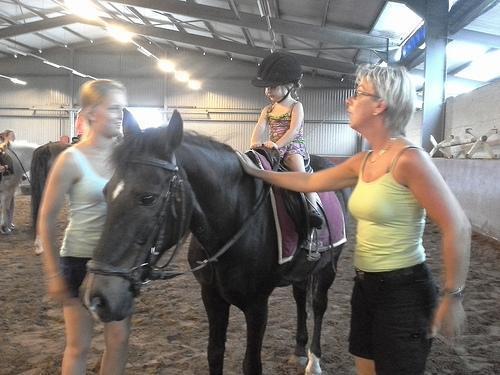How many horses are visible?
Give a very brief answer. 2. How many people are visible?
Give a very brief answer. 4. 